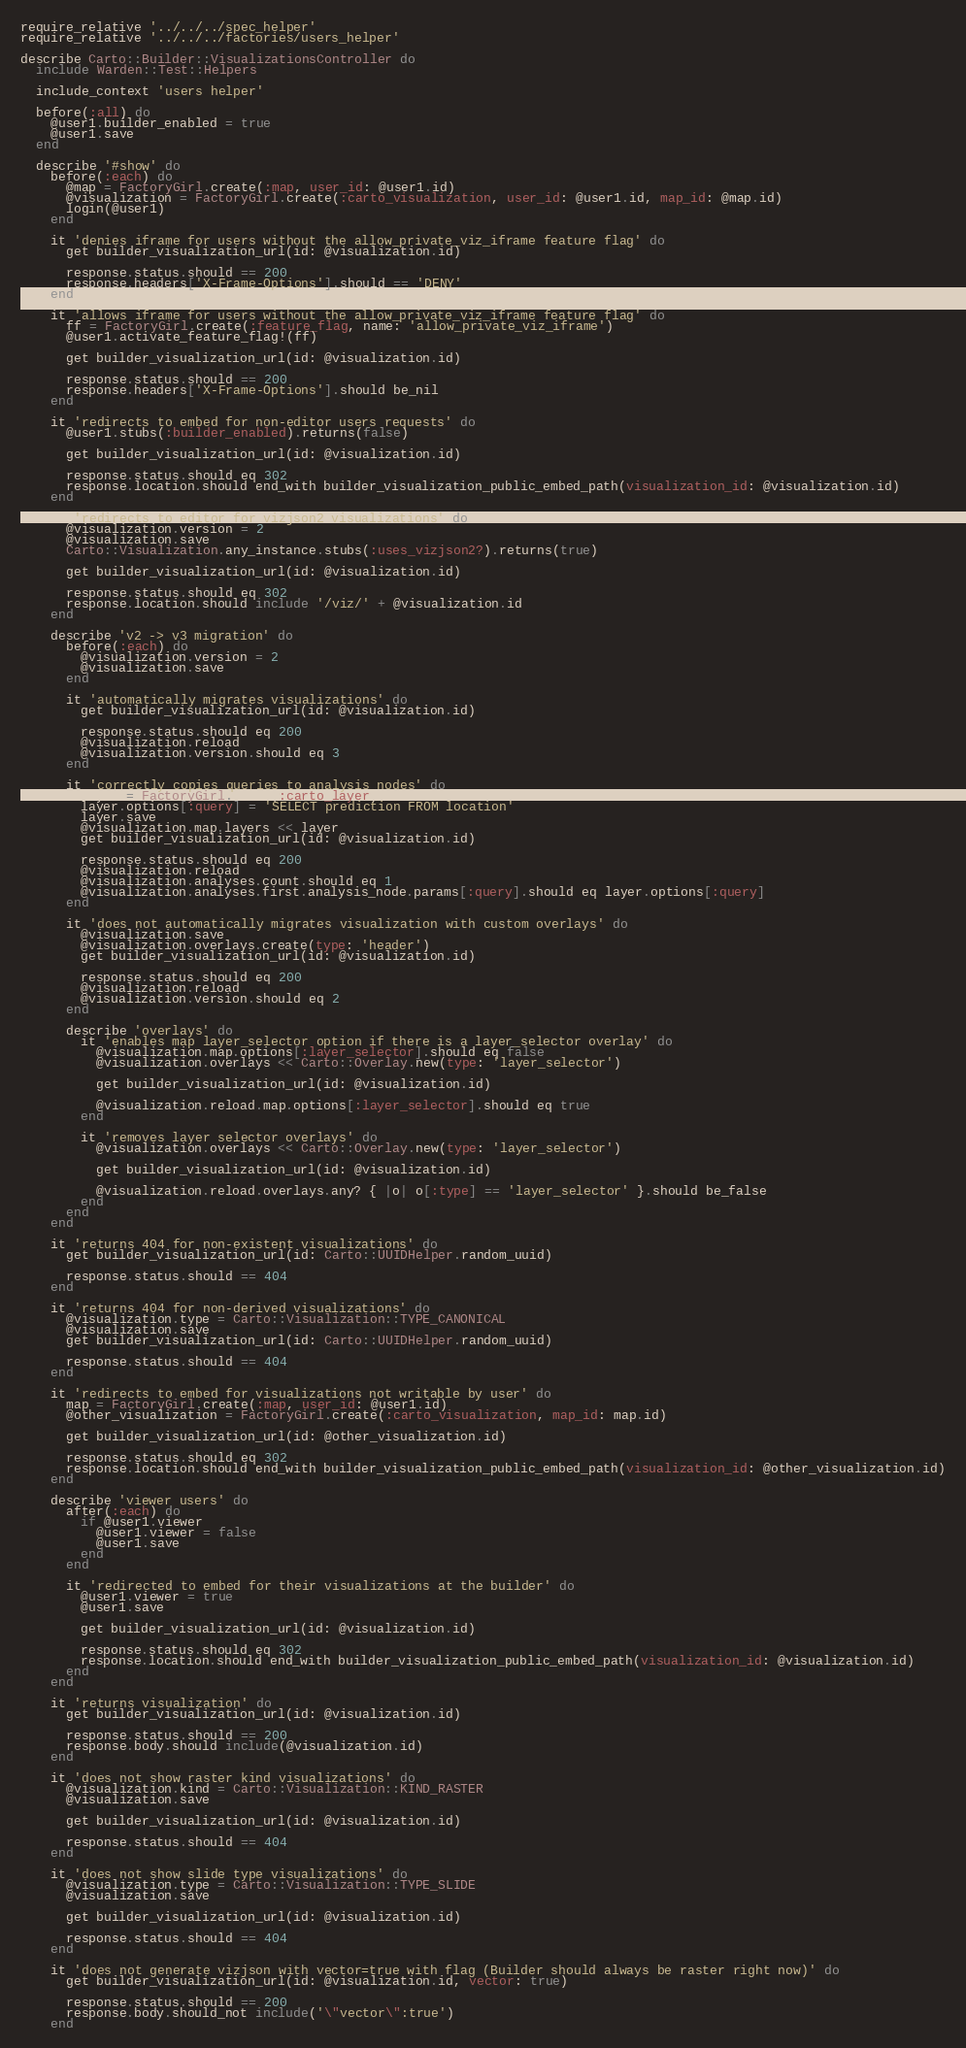<code> <loc_0><loc_0><loc_500><loc_500><_Ruby_>require_relative '../../../spec_helper'
require_relative '../../../factories/users_helper'

describe Carto::Builder::VisualizationsController do
  include Warden::Test::Helpers

  include_context 'users helper'

  before(:all) do
    @user1.builder_enabled = true
    @user1.save
  end

  describe '#show' do
    before(:each) do
      @map = FactoryGirl.create(:map, user_id: @user1.id)
      @visualization = FactoryGirl.create(:carto_visualization, user_id: @user1.id, map_id: @map.id)
      login(@user1)
    end

    it 'denies iframe for users without the allow_private_viz_iframe feature flag' do
      get builder_visualization_url(id: @visualization.id)

      response.status.should == 200
      response.headers['X-Frame-Options'].should == 'DENY'
    end

    it 'allows iframe for users without the allow_private_viz_iframe feature flag' do
      ff = FactoryGirl.create(:feature_flag, name: 'allow_private_viz_iframe')
      @user1.activate_feature_flag!(ff)

      get builder_visualization_url(id: @visualization.id)

      response.status.should == 200
      response.headers['X-Frame-Options'].should be_nil
    end

    it 'redirects to embed for non-editor users requests' do
      @user1.stubs(:builder_enabled).returns(false)

      get builder_visualization_url(id: @visualization.id)

      response.status.should eq 302
      response.location.should end_with builder_visualization_public_embed_path(visualization_id: @visualization.id)
    end

    it 'redirects to editor for vizjson2 visualizations' do
      @visualization.version = 2
      @visualization.save
      Carto::Visualization.any_instance.stubs(:uses_vizjson2?).returns(true)

      get builder_visualization_url(id: @visualization.id)

      response.status.should eq 302
      response.location.should include '/viz/' + @visualization.id
    end

    describe 'v2 -> v3 migration' do
      before(:each) do
        @visualization.version = 2
        @visualization.save
      end

      it 'automatically migrates visualizations' do
        get builder_visualization_url(id: @visualization.id)

        response.status.should eq 200
        @visualization.reload
        @visualization.version.should eq 3
      end

      it 'correctly copies queries to analysis nodes' do
        layer = FactoryGirl.build(:carto_layer)
        layer.options[:query] = 'SELECT prediction FROM location'
        layer.save
        @visualization.map.layers << layer
        get builder_visualization_url(id: @visualization.id)

        response.status.should eq 200
        @visualization.reload
        @visualization.analyses.count.should eq 1
        @visualization.analyses.first.analysis_node.params[:query].should eq layer.options[:query]
      end

      it 'does not automatically migrates visualization with custom overlays' do
        @visualization.save
        @visualization.overlays.create(type: 'header')
        get builder_visualization_url(id: @visualization.id)

        response.status.should eq 200
        @visualization.reload
        @visualization.version.should eq 2
      end

      describe 'overlays' do
        it 'enables map layer_selector option if there is a layer_selector overlay' do
          @visualization.map.options[:layer_selector].should eq false
          @visualization.overlays << Carto::Overlay.new(type: 'layer_selector')

          get builder_visualization_url(id: @visualization.id)

          @visualization.reload.map.options[:layer_selector].should eq true
        end

        it 'removes layer selector overlays' do
          @visualization.overlays << Carto::Overlay.new(type: 'layer_selector')

          get builder_visualization_url(id: @visualization.id)

          @visualization.reload.overlays.any? { |o| o[:type] == 'layer_selector' }.should be_false
        end
      end
    end

    it 'returns 404 for non-existent visualizations' do
      get builder_visualization_url(id: Carto::UUIDHelper.random_uuid)

      response.status.should == 404
    end

    it 'returns 404 for non-derived visualizations' do
      @visualization.type = Carto::Visualization::TYPE_CANONICAL
      @visualization.save
      get builder_visualization_url(id: Carto::UUIDHelper.random_uuid)

      response.status.should == 404
    end

    it 'redirects to embed for visualizations not writable by user' do
      map = FactoryGirl.create(:map, user_id: @user1.id)
      @other_visualization = FactoryGirl.create(:carto_visualization, map_id: map.id)

      get builder_visualization_url(id: @other_visualization.id)

      response.status.should eq 302
      response.location.should end_with builder_visualization_public_embed_path(visualization_id: @other_visualization.id)
    end

    describe 'viewer users' do
      after(:each) do
        if @user1.viewer
          @user1.viewer = false
          @user1.save
        end
      end

      it 'redirected to embed for their visualizations at the builder' do
        @user1.viewer = true
        @user1.save

        get builder_visualization_url(id: @visualization.id)

        response.status.should eq 302
        response.location.should end_with builder_visualization_public_embed_path(visualization_id: @visualization.id)
      end
    end

    it 'returns visualization' do
      get builder_visualization_url(id: @visualization.id)

      response.status.should == 200
      response.body.should include(@visualization.id)
    end

    it 'does not show raster kind visualizations' do
      @visualization.kind = Carto::Visualization::KIND_RASTER
      @visualization.save

      get builder_visualization_url(id: @visualization.id)

      response.status.should == 404
    end

    it 'does not show slide type visualizations' do
      @visualization.type = Carto::Visualization::TYPE_SLIDE
      @visualization.save

      get builder_visualization_url(id: @visualization.id)

      response.status.should == 404
    end

    it 'does not generate vizjson with vector=true with flag (Builder should always be raster right now)' do
      get builder_visualization_url(id: @visualization.id, vector: true)

      response.status.should == 200
      response.body.should_not include('\"vector\":true')
    end
</code> 